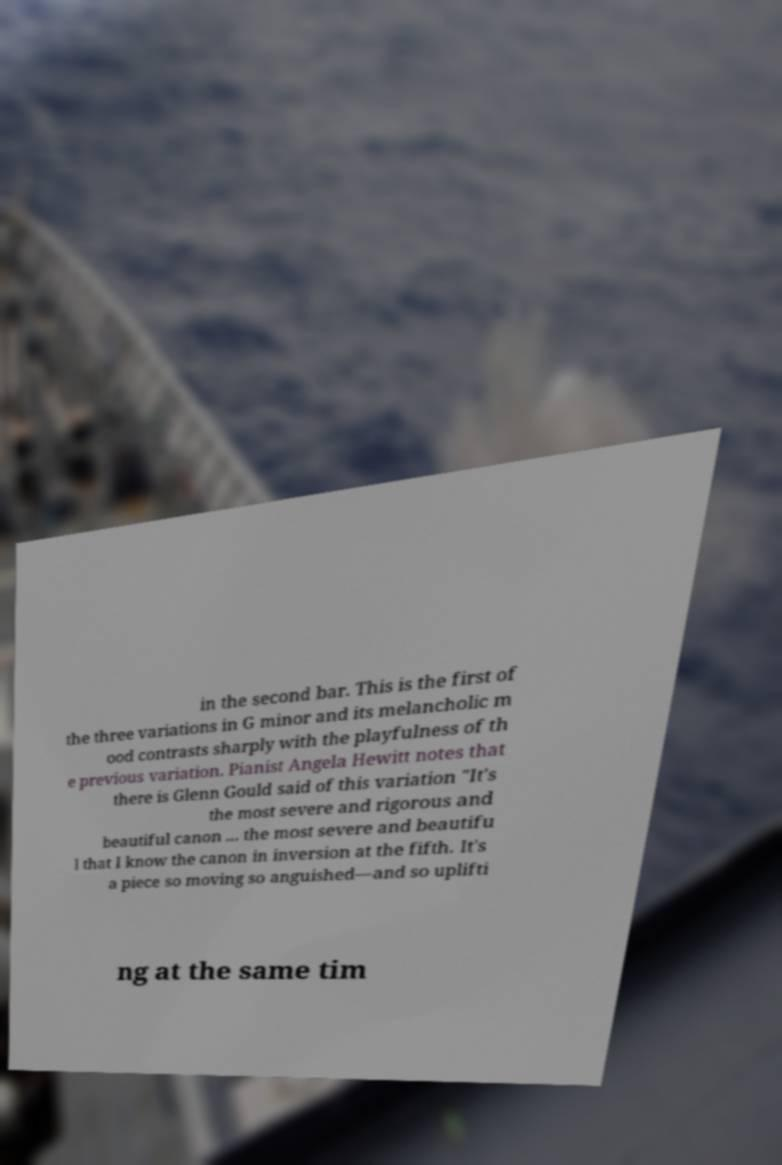Please read and relay the text visible in this image. What does it say? in the second bar. This is the first of the three variations in G minor and its melancholic m ood contrasts sharply with the playfulness of th e previous variation. Pianist Angela Hewitt notes that there is Glenn Gould said of this variation "It's the most severe and rigorous and beautiful canon ... the most severe and beautifu l that I know the canon in inversion at the fifth. It's a piece so moving so anguished—and so uplifti ng at the same tim 